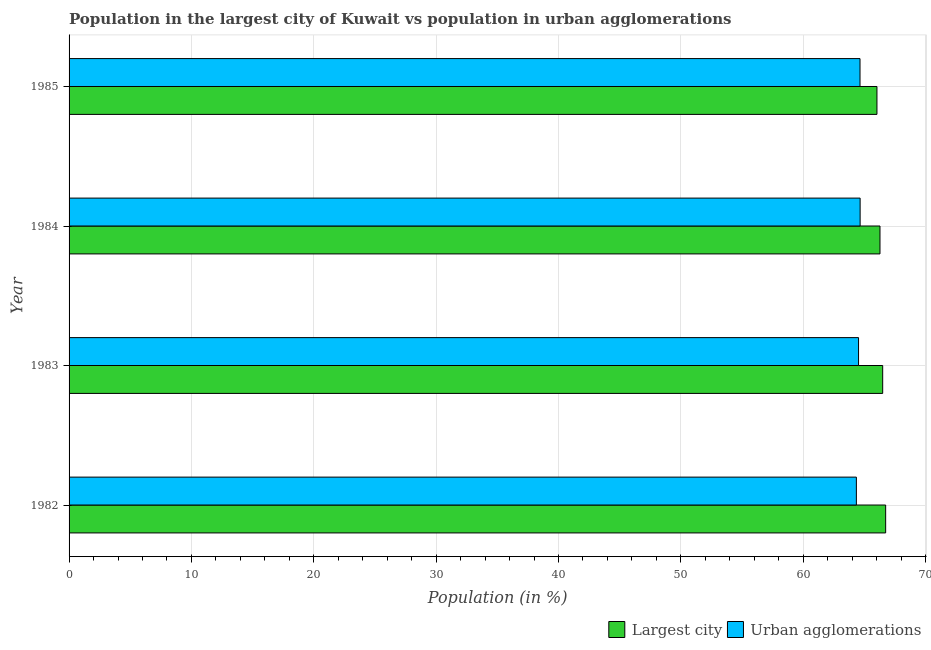Are the number of bars per tick equal to the number of legend labels?
Offer a terse response. Yes. What is the population in urban agglomerations in 1985?
Provide a short and direct response. 64.64. Across all years, what is the maximum population in the largest city?
Provide a short and direct response. 66.74. Across all years, what is the minimum population in the largest city?
Your response must be concise. 66.02. What is the total population in the largest city in the graph?
Keep it short and to the point. 265.53. What is the difference between the population in the largest city in 1983 and that in 1984?
Offer a terse response. 0.22. What is the difference between the population in the largest city in 1984 and the population in urban agglomerations in 1983?
Offer a very short reply. 1.75. What is the average population in the largest city per year?
Offer a very short reply. 66.38. In the year 1984, what is the difference between the population in urban agglomerations and population in the largest city?
Keep it short and to the point. -1.62. In how many years, is the population in the largest city greater than 26 %?
Give a very brief answer. 4. Is the difference between the population in urban agglomerations in 1984 and 1985 greater than the difference between the population in the largest city in 1984 and 1985?
Give a very brief answer. No. What is the difference between the highest and the second highest population in urban agglomerations?
Offer a very short reply. 0.01. What is the difference between the highest and the lowest population in urban agglomerations?
Provide a short and direct response. 0.31. Is the sum of the population in urban agglomerations in 1983 and 1984 greater than the maximum population in the largest city across all years?
Provide a short and direct response. Yes. What does the 2nd bar from the top in 1983 represents?
Offer a very short reply. Largest city. What does the 2nd bar from the bottom in 1983 represents?
Your response must be concise. Urban agglomerations. How many bars are there?
Your answer should be compact. 8. How many years are there in the graph?
Provide a short and direct response. 4. Does the graph contain any zero values?
Your response must be concise. No. Does the graph contain grids?
Provide a succinct answer. Yes. How many legend labels are there?
Keep it short and to the point. 2. What is the title of the graph?
Your answer should be very brief. Population in the largest city of Kuwait vs population in urban agglomerations. What is the label or title of the X-axis?
Your answer should be very brief. Population (in %). What is the Population (in %) in Largest city in 1982?
Make the answer very short. 66.74. What is the Population (in %) of Urban agglomerations in 1982?
Offer a very short reply. 64.34. What is the Population (in %) in Largest city in 1983?
Offer a terse response. 66.49. What is the Population (in %) in Urban agglomerations in 1983?
Your answer should be compact. 64.52. What is the Population (in %) in Largest city in 1984?
Your answer should be compact. 66.27. What is the Population (in %) of Urban agglomerations in 1984?
Ensure brevity in your answer.  64.65. What is the Population (in %) of Largest city in 1985?
Provide a succinct answer. 66.02. What is the Population (in %) of Urban agglomerations in 1985?
Your answer should be compact. 64.64. Across all years, what is the maximum Population (in %) of Largest city?
Your answer should be compact. 66.74. Across all years, what is the maximum Population (in %) in Urban agglomerations?
Your answer should be very brief. 64.65. Across all years, what is the minimum Population (in %) in Largest city?
Keep it short and to the point. 66.02. Across all years, what is the minimum Population (in %) of Urban agglomerations?
Give a very brief answer. 64.34. What is the total Population (in %) in Largest city in the graph?
Keep it short and to the point. 265.53. What is the total Population (in %) in Urban agglomerations in the graph?
Give a very brief answer. 258.15. What is the difference between the Population (in %) in Largest city in 1982 and that in 1983?
Your answer should be compact. 0.24. What is the difference between the Population (in %) in Urban agglomerations in 1982 and that in 1983?
Your answer should be very brief. -0.18. What is the difference between the Population (in %) in Largest city in 1982 and that in 1984?
Ensure brevity in your answer.  0.46. What is the difference between the Population (in %) in Urban agglomerations in 1982 and that in 1984?
Provide a short and direct response. -0.31. What is the difference between the Population (in %) in Largest city in 1982 and that in 1985?
Keep it short and to the point. 0.71. What is the difference between the Population (in %) in Urban agglomerations in 1982 and that in 1985?
Ensure brevity in your answer.  -0.3. What is the difference between the Population (in %) of Largest city in 1983 and that in 1984?
Ensure brevity in your answer.  0.22. What is the difference between the Population (in %) of Urban agglomerations in 1983 and that in 1984?
Give a very brief answer. -0.13. What is the difference between the Population (in %) in Largest city in 1983 and that in 1985?
Give a very brief answer. 0.47. What is the difference between the Population (in %) of Urban agglomerations in 1983 and that in 1985?
Ensure brevity in your answer.  -0.12. What is the difference between the Population (in %) of Largest city in 1984 and that in 1985?
Give a very brief answer. 0.25. What is the difference between the Population (in %) of Urban agglomerations in 1984 and that in 1985?
Provide a short and direct response. 0.01. What is the difference between the Population (in %) in Largest city in 1982 and the Population (in %) in Urban agglomerations in 1983?
Keep it short and to the point. 2.22. What is the difference between the Population (in %) of Largest city in 1982 and the Population (in %) of Urban agglomerations in 1984?
Provide a succinct answer. 2.09. What is the difference between the Population (in %) in Largest city in 1982 and the Population (in %) in Urban agglomerations in 1985?
Provide a succinct answer. 2.1. What is the difference between the Population (in %) of Largest city in 1983 and the Population (in %) of Urban agglomerations in 1984?
Your answer should be compact. 1.84. What is the difference between the Population (in %) in Largest city in 1983 and the Population (in %) in Urban agglomerations in 1985?
Offer a very short reply. 1.85. What is the difference between the Population (in %) of Largest city in 1984 and the Population (in %) of Urban agglomerations in 1985?
Provide a succinct answer. 1.63. What is the average Population (in %) in Largest city per year?
Your answer should be very brief. 66.38. What is the average Population (in %) in Urban agglomerations per year?
Provide a short and direct response. 64.54. In the year 1982, what is the difference between the Population (in %) in Largest city and Population (in %) in Urban agglomerations?
Offer a very short reply. 2.39. In the year 1983, what is the difference between the Population (in %) of Largest city and Population (in %) of Urban agglomerations?
Offer a terse response. 1.97. In the year 1984, what is the difference between the Population (in %) in Largest city and Population (in %) in Urban agglomerations?
Make the answer very short. 1.62. In the year 1985, what is the difference between the Population (in %) of Largest city and Population (in %) of Urban agglomerations?
Offer a very short reply. 1.38. What is the ratio of the Population (in %) in Urban agglomerations in 1982 to that in 1983?
Provide a short and direct response. 1. What is the ratio of the Population (in %) of Largest city in 1982 to that in 1984?
Your answer should be compact. 1.01. What is the ratio of the Population (in %) of Urban agglomerations in 1982 to that in 1984?
Make the answer very short. 1. What is the ratio of the Population (in %) of Largest city in 1982 to that in 1985?
Offer a terse response. 1.01. What is the ratio of the Population (in %) of Urban agglomerations in 1982 to that in 1985?
Make the answer very short. 1. What is the ratio of the Population (in %) of Largest city in 1983 to that in 1984?
Give a very brief answer. 1. What is the ratio of the Population (in %) of Largest city in 1983 to that in 1985?
Keep it short and to the point. 1.01. What is the ratio of the Population (in %) of Urban agglomerations in 1983 to that in 1985?
Provide a short and direct response. 1. What is the ratio of the Population (in %) in Largest city in 1984 to that in 1985?
Your response must be concise. 1. What is the ratio of the Population (in %) in Urban agglomerations in 1984 to that in 1985?
Ensure brevity in your answer.  1. What is the difference between the highest and the second highest Population (in %) in Largest city?
Give a very brief answer. 0.24. What is the difference between the highest and the second highest Population (in %) in Urban agglomerations?
Give a very brief answer. 0.01. What is the difference between the highest and the lowest Population (in %) of Largest city?
Provide a succinct answer. 0.71. What is the difference between the highest and the lowest Population (in %) in Urban agglomerations?
Ensure brevity in your answer.  0.31. 